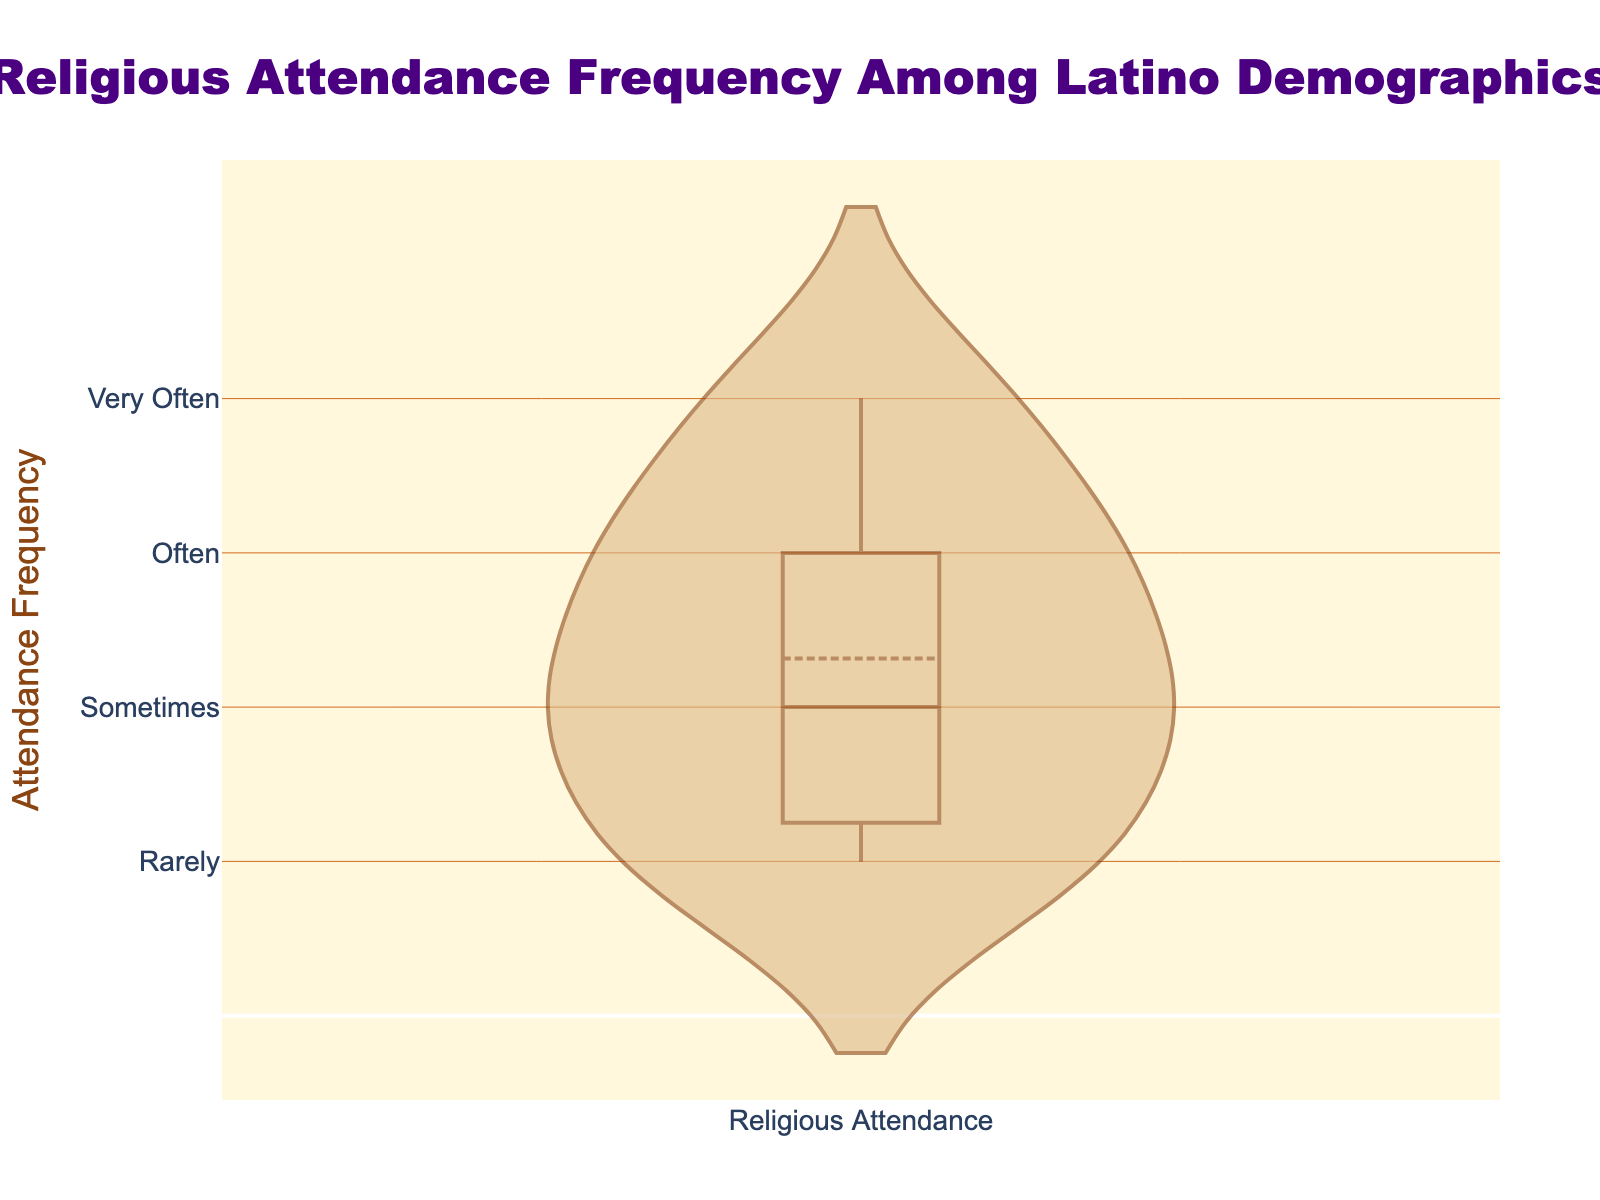Which demographic is the violin chart visualizing? The title of the chart indicates that the figure visualizes "Religious Attendance Frequency Among Latino Demographics."
Answer: Latino demographics What is the y-axis title, and what does it represent? The y-axis title is "Attendance Frequency," representing how often individuals attend religious services.
Answer: Attendance Frequency What are the four categories of attendance frequency shown on the y-axis? The y-axis uses tick labels "Rarely," "Sometimes," "Often," and "Very Often" to categorize attendance frequency.
Answer: Rarely, Sometimes, Often, Very Often What is the central color scheme used in the violin plot? The violin plot uses brown colors, with the line color being a darker brown and the fill color being a lighter brown (comparable to shades of brown like #8B4513 and #DEB887).
Answer: Brown colors Which attendance frequency appears to be the median value in the violin plot? The median value is indicated by the white line within the box plot overlay, which appears to be at "Sometimes."
Answer: Sometimes What patterns can be observed regarding the spread of data points in the violin plot? The violin plot shows data points spread across all categories ("Rarely" to "Very Often"), with thicker parts indicating higher data density around "Sometimes" and "Often."
Answer: Higher data density around "Sometimes" and "Often" Which category of attendance frequency has the most variability in the data? The widths of the violin plot show variability, with "Sometimes" showing a broader spread, suggesting greater variability.
Answer: Sometimes Is the mean line visible, and if so, where is it located relative to the median? Yes, the mean line is visible and is plotted as a white dashed line, which also appears to be close to "Sometimes" similar to the median.
Answer: Yes, near "Sometimes" Compare the attendance frequency of 'Rarely' and 'Very Often.' Which has more data concentration? The width of the violin plot at 'Rarely' is thinner compared to 'Very Often,' indicating less data concentration at 'Rarely' than 'Very Often.'
Answer: More concentration at 'Very Often' How does the data depicting 'Often' attendance frequency compare to 'Sometimes'? Both 'Often' and 'Sometimes' show significant data concentration, but 'Sometimes' has a broader base indicating a slightly higher concentration of data points.
Answer: 'Sometimes' has a slightly higher concentration 